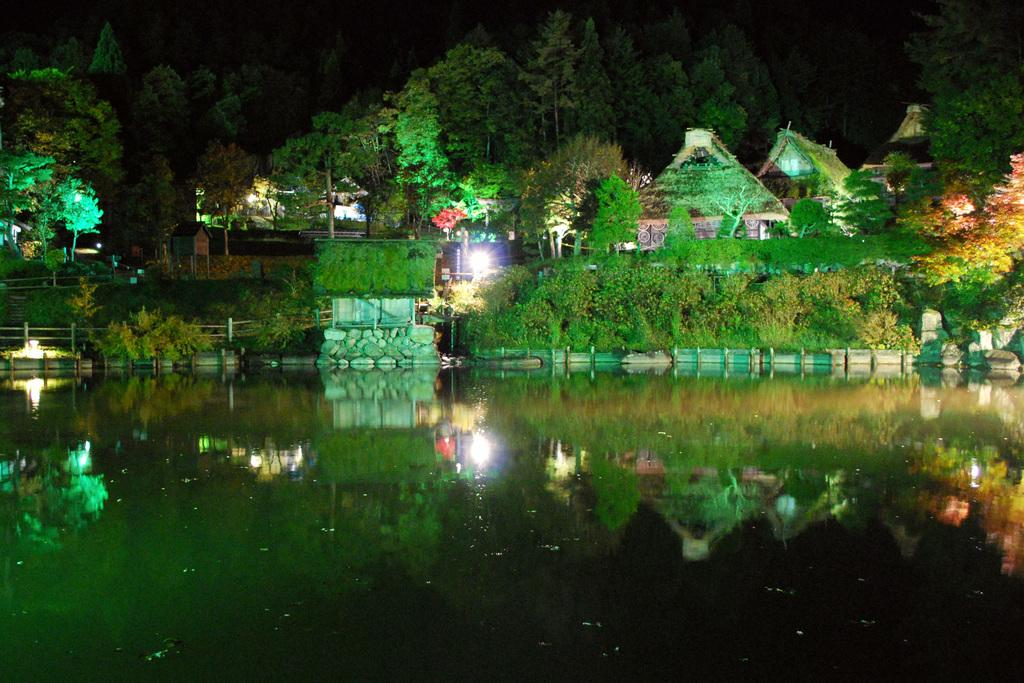What is the primary element visible in the image? There is water in the image. What type of vegetation can be seen in the image? There are plants, grass, and trees in the image. What type of structures are present in the image? There are houses in the image. What other objects can be seen in the image? There are other objects in the image, but their specific nature is not mentioned in the provided facts. What part of the body is visible in the image? There is no part of the body visible in the image; the focus is on water, vegetation, structures, and other objects. 